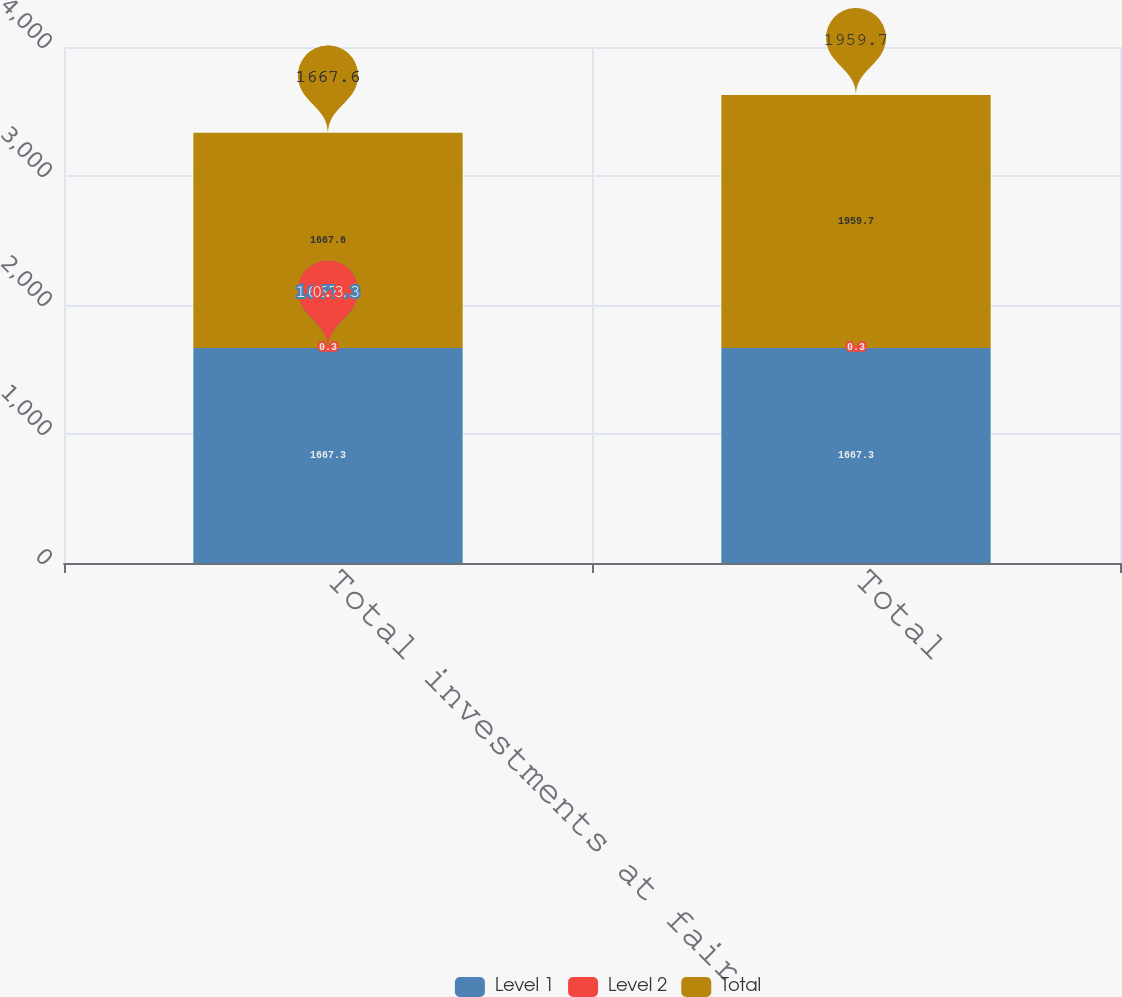<chart> <loc_0><loc_0><loc_500><loc_500><stacked_bar_chart><ecel><fcel>Total investments at fair<fcel>Total<nl><fcel>Level 1<fcel>1667.3<fcel>1667.3<nl><fcel>Level 2<fcel>0.3<fcel>0.3<nl><fcel>Total<fcel>1667.6<fcel>1959.7<nl></chart> 